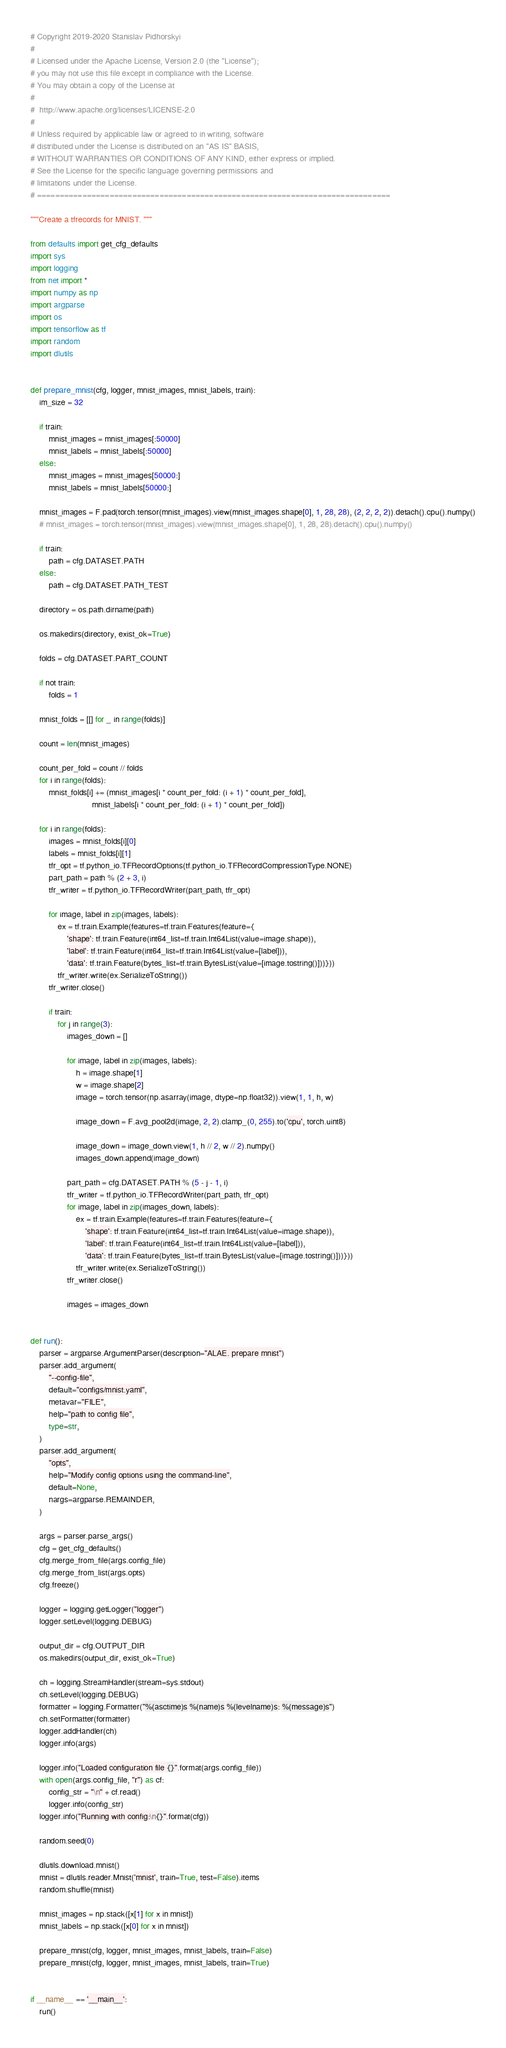<code> <loc_0><loc_0><loc_500><loc_500><_Python_># Copyright 2019-2020 Stanislav Pidhorskyi
#
# Licensed under the Apache License, Version 2.0 (the "License");
# you may not use this file except in compliance with the License.
# You may obtain a copy of the License at
#
#  http://www.apache.org/licenses/LICENSE-2.0
#
# Unless required by applicable law or agreed to in writing, software
# distributed under the License is distributed on an "AS IS" BASIS,
# WITHOUT WARRANTIES OR CONDITIONS OF ANY KIND, either express or implied.
# See the License for the specific language governing permissions and
# limitations under the License.
# ==============================================================================

"""Create a tfrecords for MNIST. """

from defaults import get_cfg_defaults
import sys
import logging
from net import *
import numpy as np
import argparse
import os
import tensorflow as tf
import random
import dlutils


def prepare_mnist(cfg, logger, mnist_images, mnist_labels, train):
    im_size = 32

    if train:
        mnist_images = mnist_images[:50000]
        mnist_labels = mnist_labels[:50000]
    else:
        mnist_images = mnist_images[50000:]
        mnist_labels = mnist_labels[50000:]

    mnist_images = F.pad(torch.tensor(mnist_images).view(mnist_images.shape[0], 1, 28, 28), (2, 2, 2, 2)).detach().cpu().numpy()
    # mnist_images = torch.tensor(mnist_images).view(mnist_images.shape[0], 1, 28, 28).detach().cpu().numpy()

    if train:
        path = cfg.DATASET.PATH
    else:
        path = cfg.DATASET.PATH_TEST

    directory = os.path.dirname(path)

    os.makedirs(directory, exist_ok=True)

    folds = cfg.DATASET.PART_COUNT

    if not train:
        folds = 1

    mnist_folds = [[] for _ in range(folds)]

    count = len(mnist_images)

    count_per_fold = count // folds
    for i in range(folds):
        mnist_folds[i] += (mnist_images[i * count_per_fold: (i + 1) * count_per_fold],
                           mnist_labels[i * count_per_fold: (i + 1) * count_per_fold])

    for i in range(folds):
        images = mnist_folds[i][0]
        labels = mnist_folds[i][1]
        tfr_opt = tf.python_io.TFRecordOptions(tf.python_io.TFRecordCompressionType.NONE)
        part_path = path % (2 + 3, i)
        tfr_writer = tf.python_io.TFRecordWriter(part_path, tfr_opt)

        for image, label in zip(images, labels):
            ex = tf.train.Example(features=tf.train.Features(feature={
                'shape': tf.train.Feature(int64_list=tf.train.Int64List(value=image.shape)),
                'label': tf.train.Feature(int64_list=tf.train.Int64List(value=[label])),
                'data': tf.train.Feature(bytes_list=tf.train.BytesList(value=[image.tostring()]))}))
            tfr_writer.write(ex.SerializeToString())
        tfr_writer.close()

        if train:
            for j in range(3):
                images_down = []

                for image, label in zip(images, labels):
                    h = image.shape[1]
                    w = image.shape[2]
                    image = torch.tensor(np.asarray(image, dtype=np.float32)).view(1, 1, h, w)

                    image_down = F.avg_pool2d(image, 2, 2).clamp_(0, 255).to('cpu', torch.uint8)

                    image_down = image_down.view(1, h // 2, w // 2).numpy()
                    images_down.append(image_down)

                part_path = cfg.DATASET.PATH % (5 - j - 1, i)
                tfr_writer = tf.python_io.TFRecordWriter(part_path, tfr_opt)
                for image, label in zip(images_down, labels):
                    ex = tf.train.Example(features=tf.train.Features(feature={
                        'shape': tf.train.Feature(int64_list=tf.train.Int64List(value=image.shape)),
                        'label': tf.train.Feature(int64_list=tf.train.Int64List(value=[label])),
                        'data': tf.train.Feature(bytes_list=tf.train.BytesList(value=[image.tostring()]))}))
                    tfr_writer.write(ex.SerializeToString())
                tfr_writer.close()

                images = images_down


def run():
    parser = argparse.ArgumentParser(description="ALAE. prepare mnist")
    parser.add_argument(
        "--config-file",
        default="configs/mnist.yaml",
        metavar="FILE",
        help="path to config file",
        type=str,
    )
    parser.add_argument(
        "opts",
        help="Modify config options using the command-line",
        default=None,
        nargs=argparse.REMAINDER,
    )

    args = parser.parse_args()
    cfg = get_cfg_defaults()
    cfg.merge_from_file(args.config_file)
    cfg.merge_from_list(args.opts)
    cfg.freeze()

    logger = logging.getLogger("logger")
    logger.setLevel(logging.DEBUG)

    output_dir = cfg.OUTPUT_DIR
    os.makedirs(output_dir, exist_ok=True)

    ch = logging.StreamHandler(stream=sys.stdout)
    ch.setLevel(logging.DEBUG)
    formatter = logging.Formatter("%(asctime)s %(name)s %(levelname)s: %(message)s")
    ch.setFormatter(formatter)
    logger.addHandler(ch)
    logger.info(args)

    logger.info("Loaded configuration file {}".format(args.config_file))
    with open(args.config_file, "r") as cf:
        config_str = "\n" + cf.read()
        logger.info(config_str)
    logger.info("Running with config:\n{}".format(cfg))

    random.seed(0)

    dlutils.download.mnist()
    mnist = dlutils.reader.Mnist('mnist', train=True, test=False).items
    random.shuffle(mnist)

    mnist_images = np.stack([x[1] for x in mnist])
    mnist_labels = np.stack([x[0] for x in mnist])

    prepare_mnist(cfg, logger, mnist_images, mnist_labels, train=False)
    prepare_mnist(cfg, logger, mnist_images, mnist_labels, train=True)


if __name__ == '__main__':
    run()
</code> 